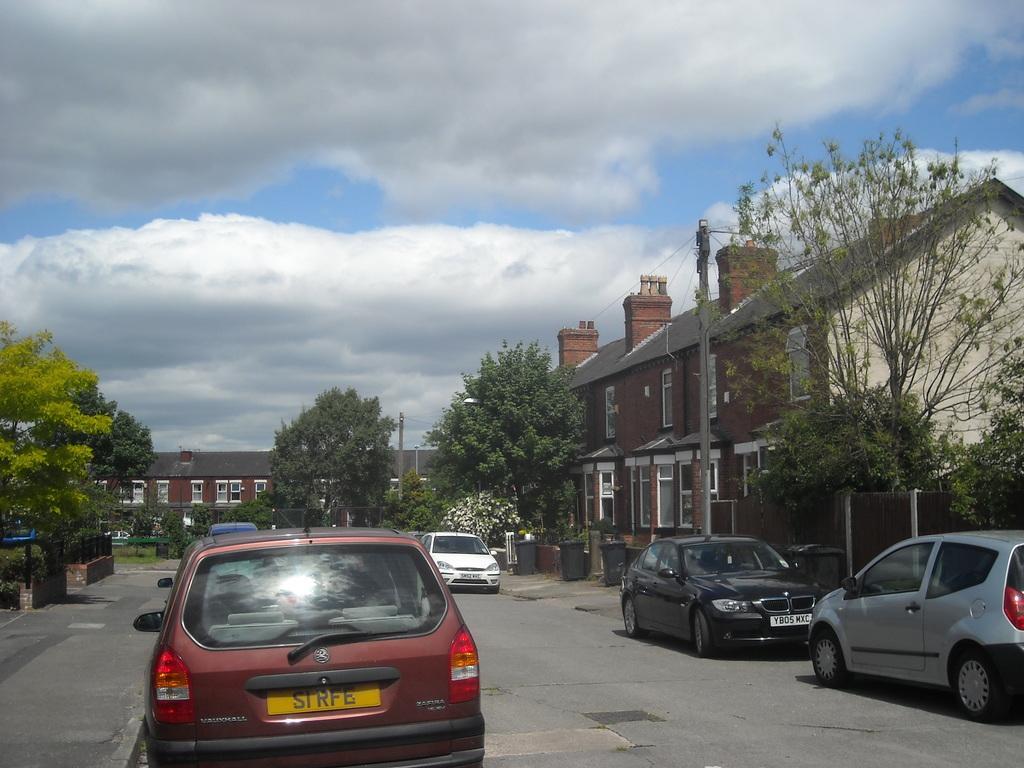Can you describe this image briefly? In this image, there are a few houses, vehicles, trees, plants, poles and wires. We can see the ground with some objects. We can also see the sky with clouds. We can also see some trash cans. 